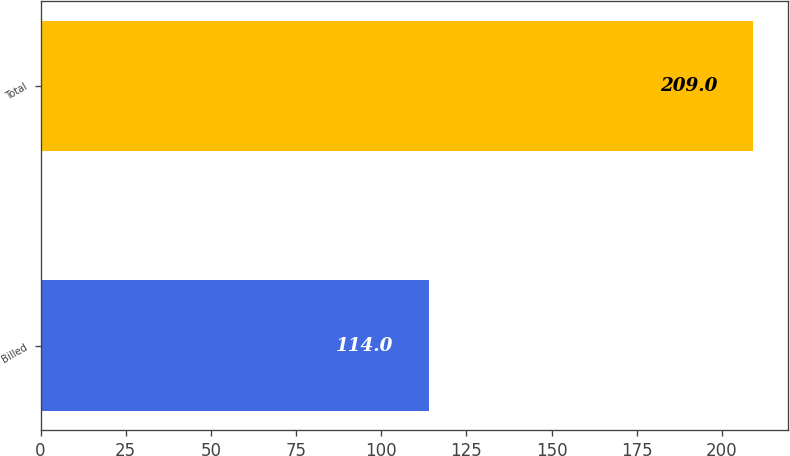<chart> <loc_0><loc_0><loc_500><loc_500><bar_chart><fcel>Billed<fcel>Total<nl><fcel>114<fcel>209<nl></chart> 